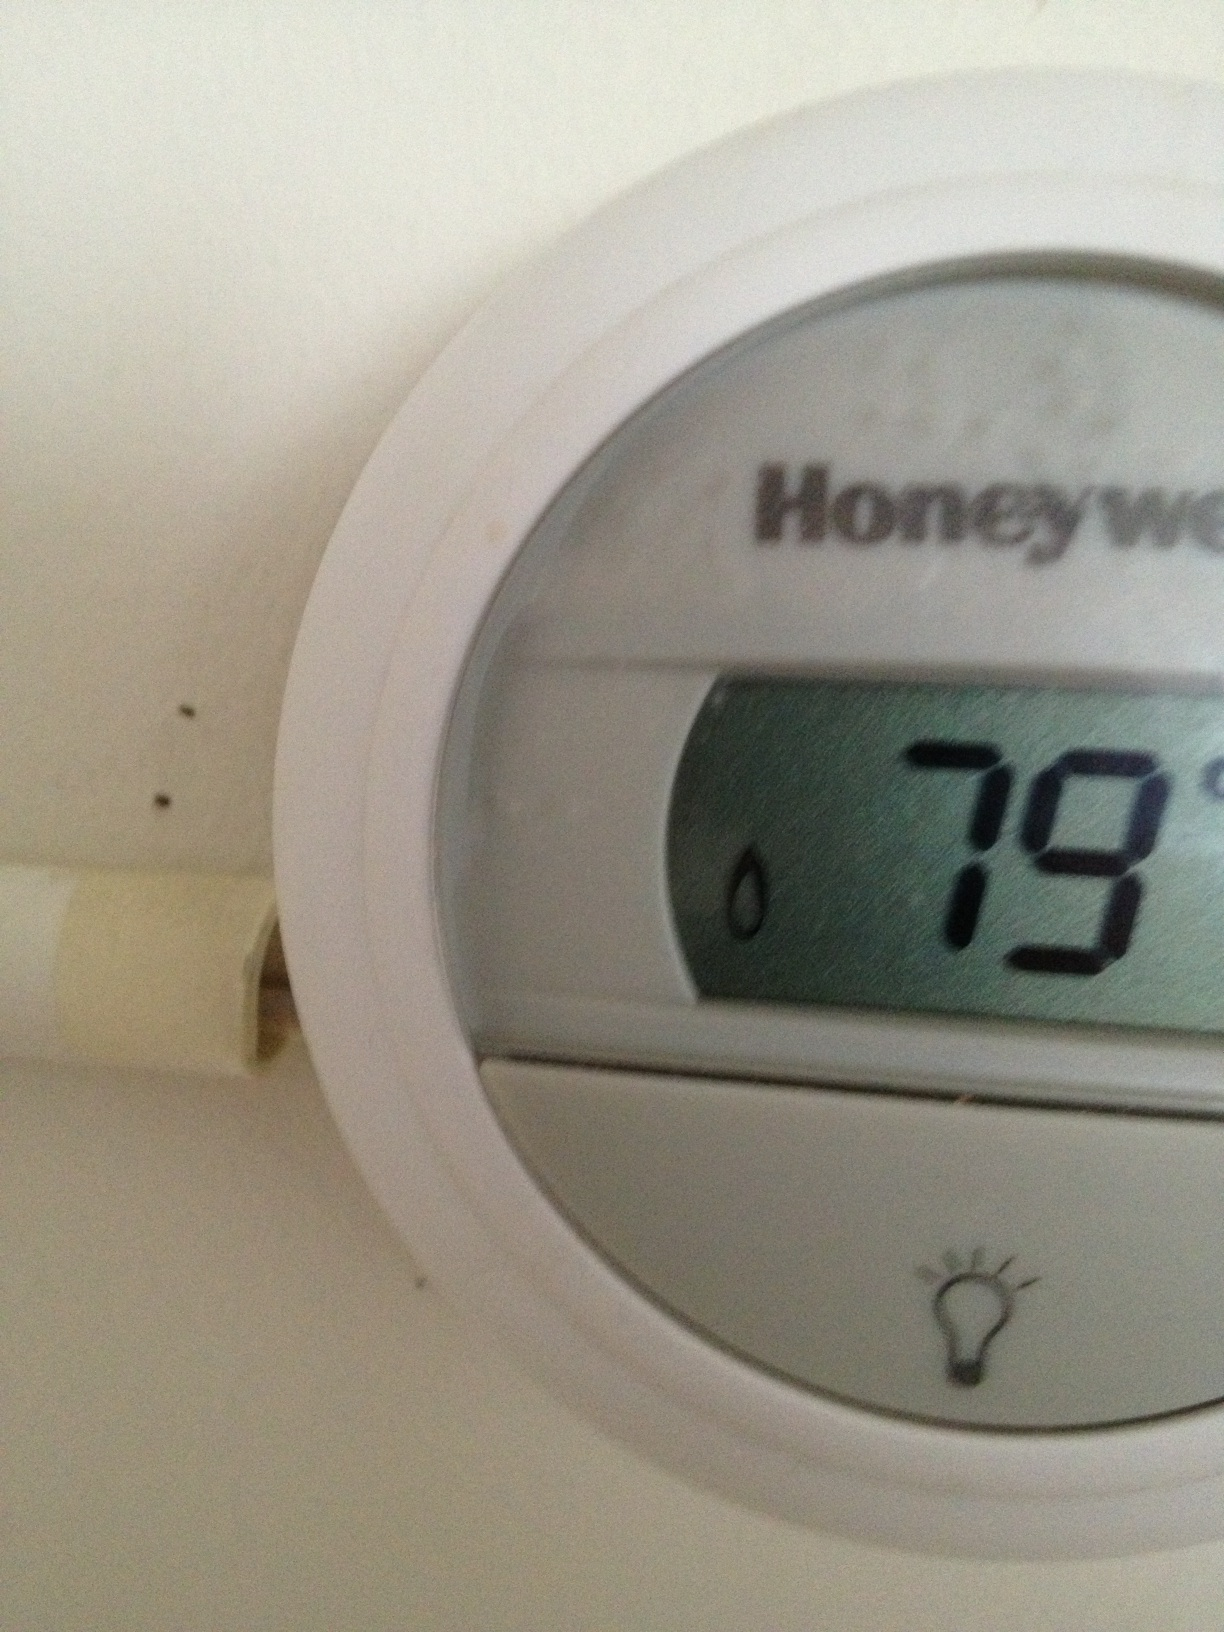How might I adjust the temperature? Typically, thermostats like the one shown have buttons or a user interface to set the desired temperature. You would press the appropriate arrow or plus/minus button to raise or lower the temperature setting. 